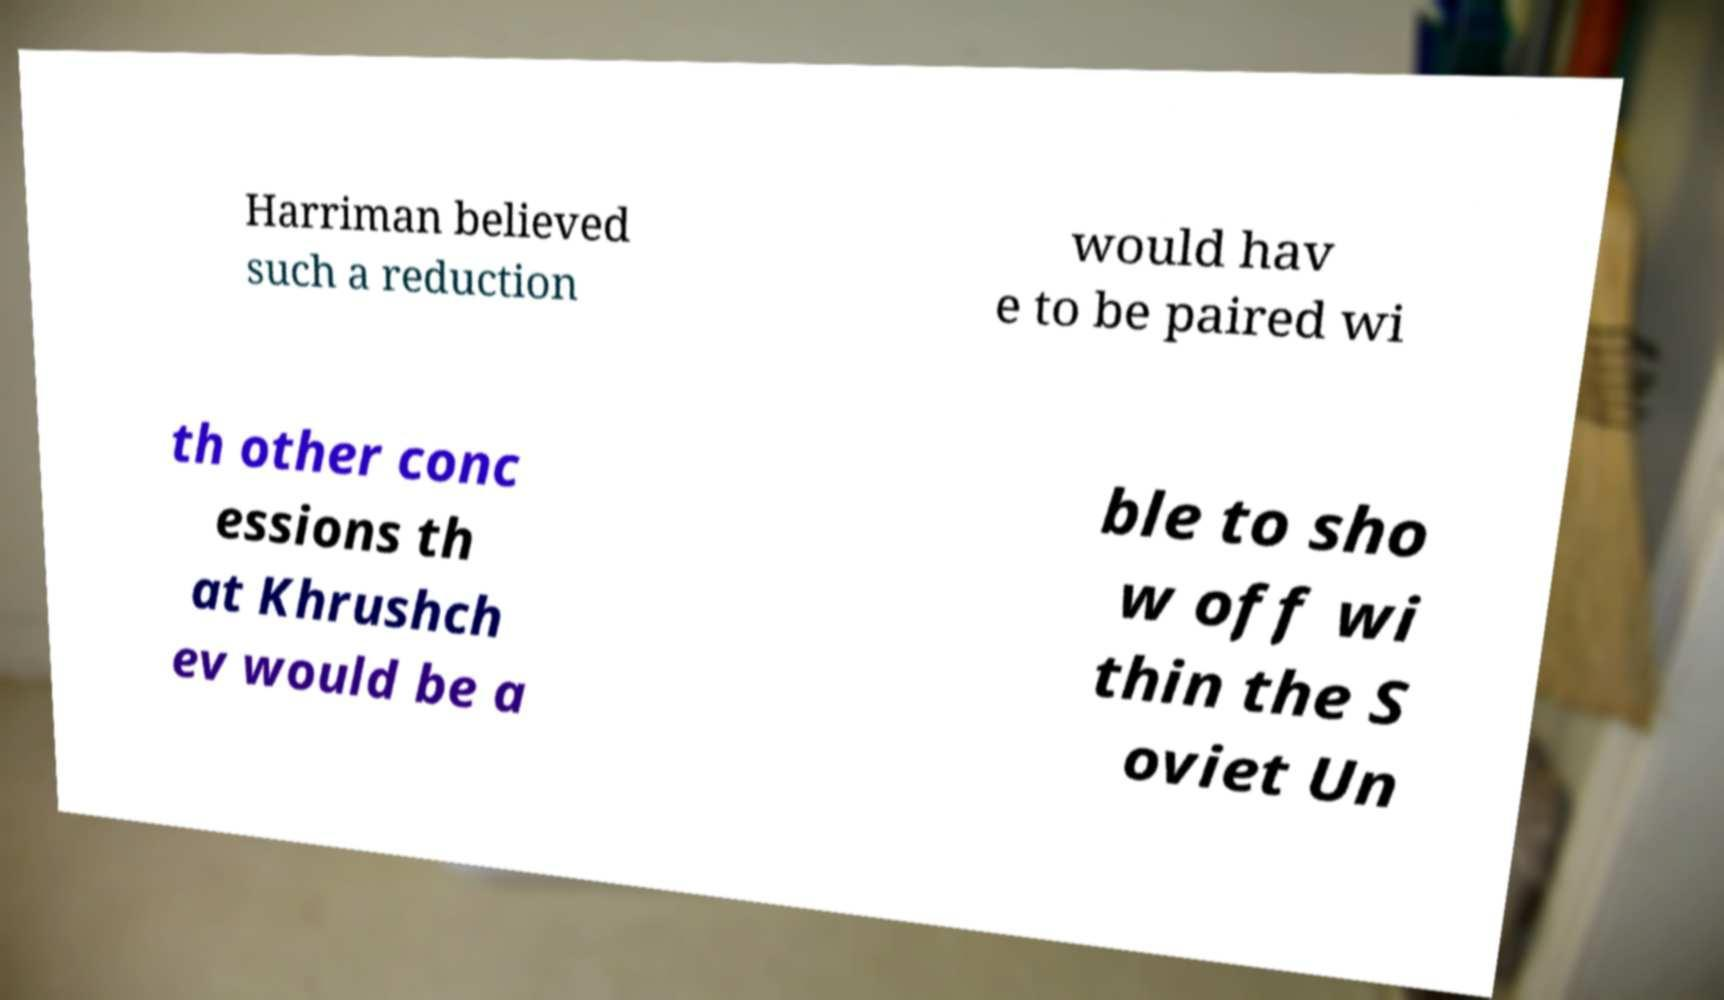I need the written content from this picture converted into text. Can you do that? Harriman believed such a reduction would hav e to be paired wi th other conc essions th at Khrushch ev would be a ble to sho w off wi thin the S oviet Un 